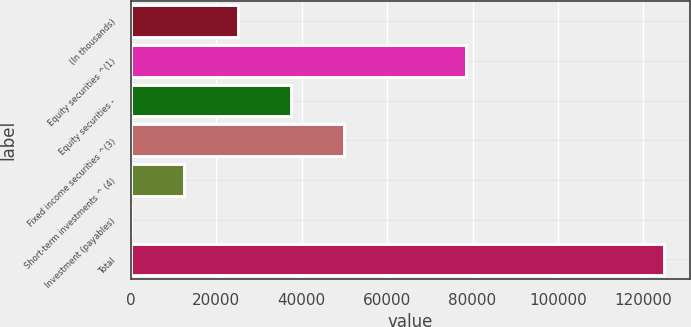<chart> <loc_0><loc_0><loc_500><loc_500><bar_chart><fcel>(In thousands)<fcel>Equity securities ^(1)<fcel>Equity securities -<fcel>Fixed income securities ^(3)<fcel>Short-term investments ^ (4)<fcel>Investment (payables)<fcel>Total<nl><fcel>24989.6<fcel>78576<fcel>37454.9<fcel>49920.2<fcel>12524.3<fcel>59<fcel>124712<nl></chart> 